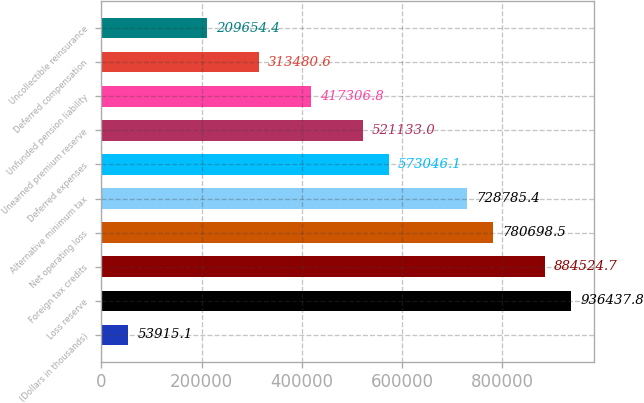Convert chart to OTSL. <chart><loc_0><loc_0><loc_500><loc_500><bar_chart><fcel>(Dollars in thousands)<fcel>Loss reserve<fcel>Foreign tax credits<fcel>Net operating loss<fcel>Alternative minimum tax<fcel>Deferred expenses<fcel>Unearned premium reserve<fcel>Unfunded pension liability<fcel>Deferred compensation<fcel>Uncollectible reinsurance<nl><fcel>53915.1<fcel>936438<fcel>884525<fcel>780698<fcel>728785<fcel>573046<fcel>521133<fcel>417307<fcel>313481<fcel>209654<nl></chart> 